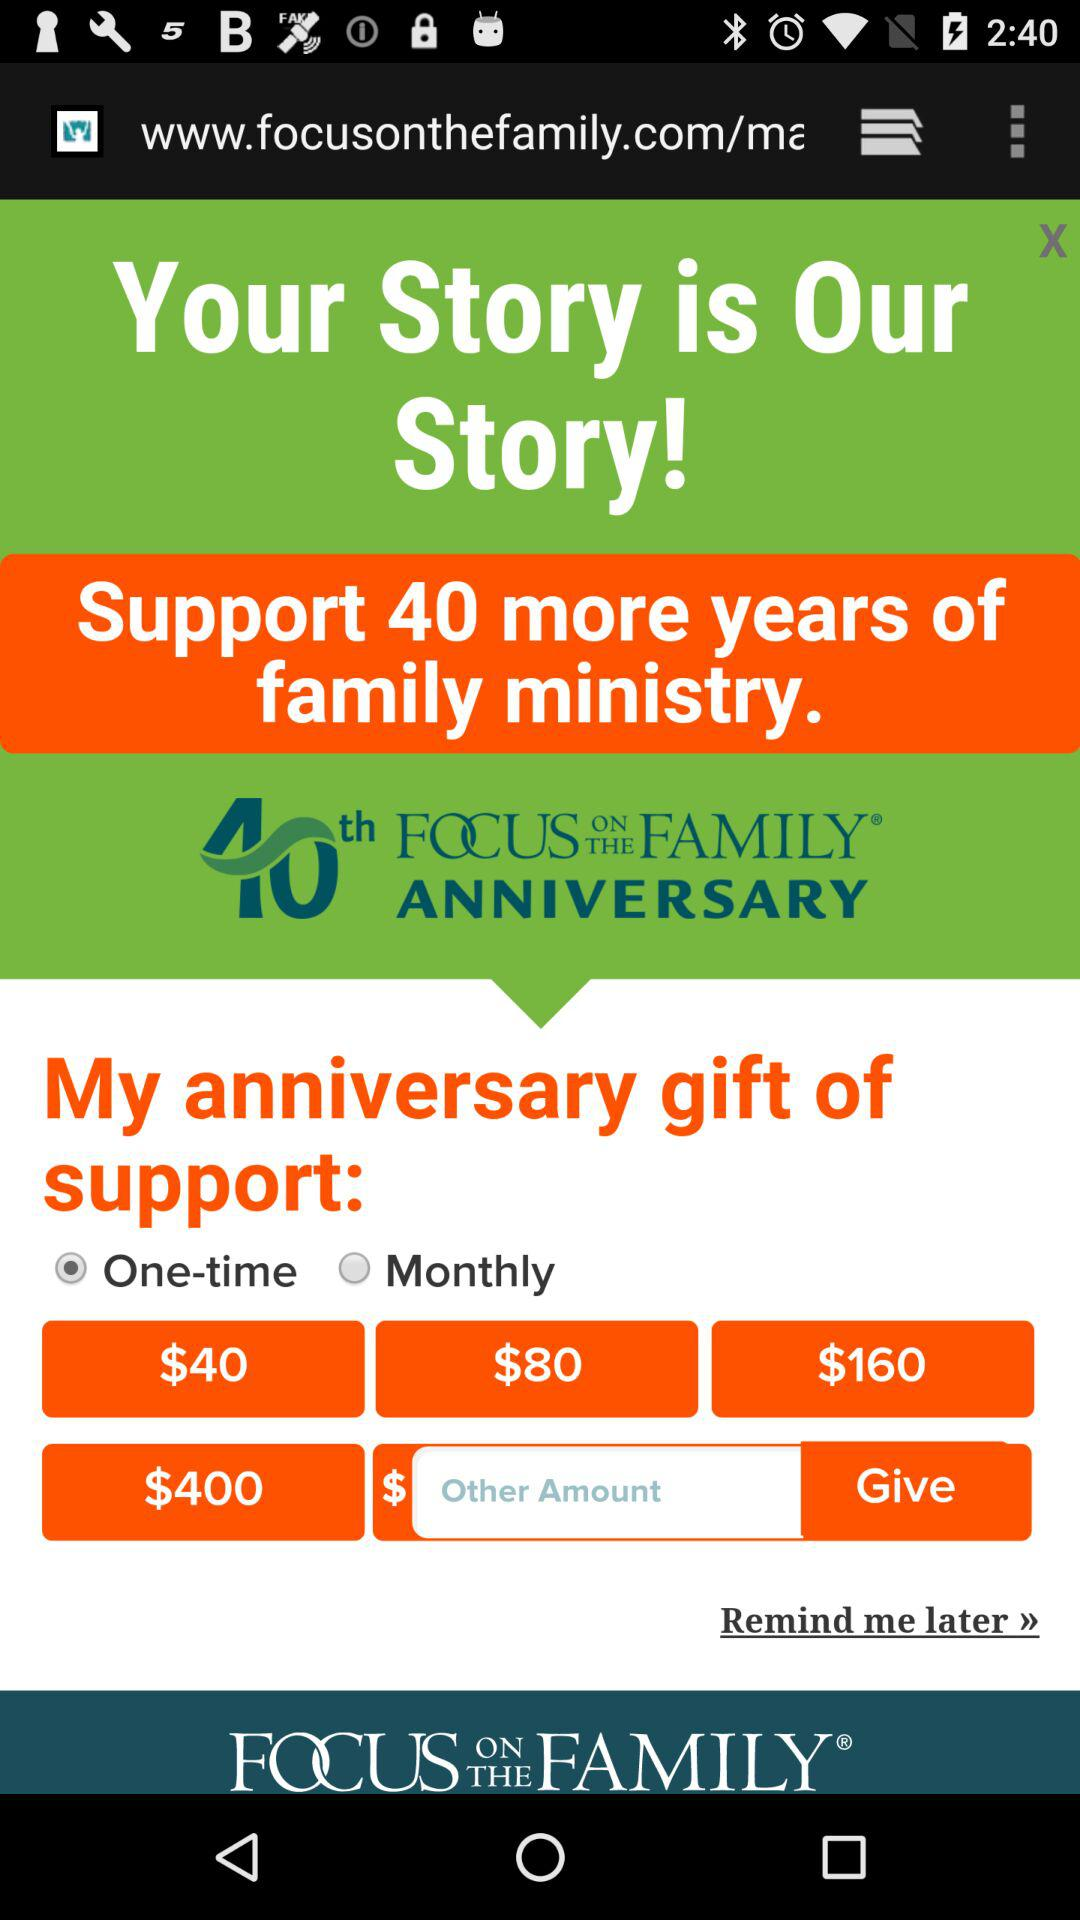What are the given price options? The given price options are $40, $80, $160 and $400. 